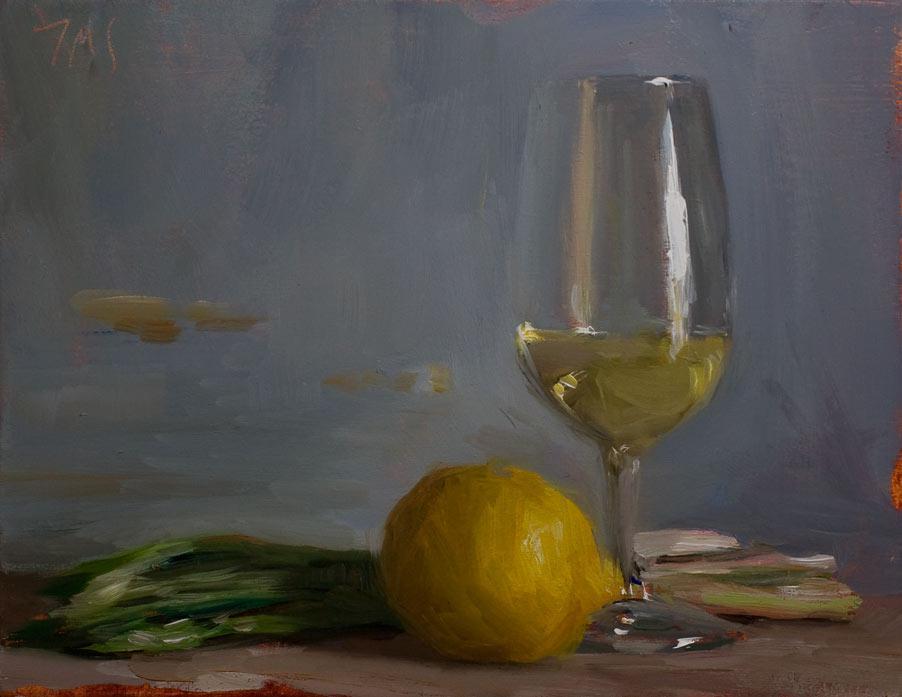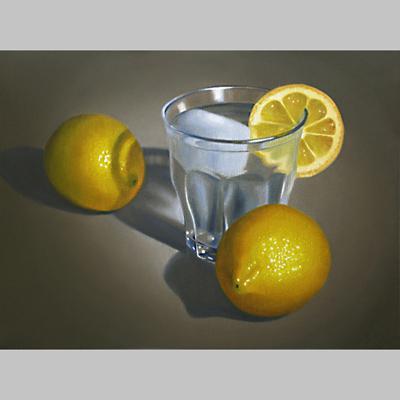The first image is the image on the left, the second image is the image on the right. Given the left and right images, does the statement "The left image depicts a stemmed glass next to a whole lemon, and the right image includes a glass of clear liquid and a sliced fruit." hold true? Answer yes or no. Yes. The first image is the image on the left, the second image is the image on the right. Examine the images to the left and right. Is the description "At least three whole lemons are sitting near a container of water in the image on the right." accurate? Answer yes or no. No. 